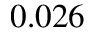Convert formula to latex. <formula><loc_0><loc_0><loc_500><loc_500>0 . 0 2 6</formula> 